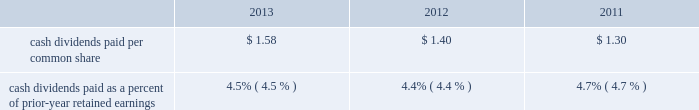Net cash used by investing activities in 2013 also included $ 38.2 million for the may 13 , 2013 acquisition of challenger .
See note 2 to the consolidated financial statements for information on the challenger acquisition .
Capital expenditures in 2013 , 2012 and 2011 totaled $ 70.6 million , $ 79.4 million and $ 61.2 million , respectively .
Capital expenditures in 2013 included continued investments related to the company 2019s execution of its strategic value creation processes around safety , quality , customer connection , innovation and rci initiatives .
Capital expenditures in all three years included spending to support the company 2019s strategic growth initiatives .
In 2013 , the company continued to invest in new product , efficiency , safety and cost reduction initiatives to expand and improve its manufacturing capabilities worldwide .
In 2012 , the company completed the construction of a fourth factory in kunshan , china , following the 2011 construction of a new engineering and research and development facility in kunshan .
Capital expenditures in all three years also included investments , particularly in the united states , in new product , efficiency , safety and cost reduction initiatives , as well as investments in new production and machine tooling to enhance manufacturing operations , and ongoing replacements of manufacturing and distribution equipment .
Capital spending in all three years also included spending for the replacement and enhancement of the company 2019s global enterprise resource planning ( erp ) management information systems , as well as spending to enhance the company 2019s corporate headquarters and research and development facilities in kenosha , wisconsin .
Snap-on believes that its cash generated from operations , as well as its available cash on hand and funds available from its credit facilities will be sufficient to fund the company 2019s capital expenditure requirements in 2014 .
Financing activities net cash used by financing activities was $ 137.8 million in 2013 , $ 127.0 million in 2012 and $ 293.7 million in 2011 .
Net cash used by financing activities in 2011 reflects the august 2011 repayment of $ 200 million of unsecured 6.25% ( 6.25 % ) notes upon maturity with available cash .
Proceeds from stock purchase and option plan exercises totaled $ 29.2 million in 2013 , $ 46.8 million in 2012 and $ 25.7 million in 2011 .
Snap-on has undertaken stock repurchases from time to time to offset dilution created by shares issued for employee and franchisee stock purchase plans , stock options and other corporate purposes .
In 2013 , snap-on repurchased 926000 shares of its common stock for $ 82.6 million under its previously announced share repurchase programs .
As of 2013 year end , snap-on had remaining availability to repurchase up to an additional $ 191.7 million in common stock pursuant to its board of directors 2019 ( the 201cboard 201d ) authorizations .
The purchase of snap-on common stock is at the company 2019s discretion , subject to prevailing financial and market conditions .
Snap-on repurchased 1180000 shares of its common stock for $ 78.1 million in 2012 ; snap-on repurchased 628000 shares of its common stock for $ 37.4 million in 2011 .
Snap-on believes that its cash generated from operations , available cash on hand , and funds available from its credit facilities , will be sufficient to fund the company 2019s share repurchases , if any , in 2014 .
Snap-on has paid consecutive quarterly cash dividends , without interruption or reduction , since 1939 .
Cash dividends paid in 2013 , 2012 and 2011 totaled $ 92.0 million , $ 81.5 million and $ 76.7 million , respectively .
On november 8 , 2013 , the company announced that its board increased the quarterly cash dividend by 15.8% ( 15.8 % ) to $ 0.44 per share ( $ 1.76 per share per year ) .
Quarterly dividends declared in 2013 were $ 0.44 per share in the fourth quarter and $ 0.38 per share in the first three quarters ( $ 1.58 per share for the year ) .
Quarterly dividends declared in 2012 were $ 0.38 per share in the fourth quarter and $ 0.34 per share in the first three quarters ( $ 1.40 per share for the year ) .
Quarterly dividends in 2011 were $ 0.34 per share in the fourth quarter and $ 0.32 per share in the first three quarters ( $ 1.30 per share for the year ) . .
Cash dividends paid as a percent of prior-year retained earnings 4.5% ( 4.5 % ) 4.4% ( 4.4 % ) snap-on believes that its cash generated from operations , available cash on hand and funds available from its credit facilities will be sufficient to pay dividends in 2014 .
Off-balance-sheet arrangements except as included below in the section labeled 201ccontractual obligations and commitments 201d and note 15 to the consolidated financial statements , the company had no off-balance-sheet arrangements as of 2013 year end .
2013 annual report 49 .
What was the average capital expenditures from 2011 to 2013 in millions? 
Computations: (((61.2 + (70.6 + 79.4)) + 3) / 2)
Answer: 107.1. Net cash used by investing activities in 2013 also included $ 38.2 million for the may 13 , 2013 acquisition of challenger .
See note 2 to the consolidated financial statements for information on the challenger acquisition .
Capital expenditures in 2013 , 2012 and 2011 totaled $ 70.6 million , $ 79.4 million and $ 61.2 million , respectively .
Capital expenditures in 2013 included continued investments related to the company 2019s execution of its strategic value creation processes around safety , quality , customer connection , innovation and rci initiatives .
Capital expenditures in all three years included spending to support the company 2019s strategic growth initiatives .
In 2013 , the company continued to invest in new product , efficiency , safety and cost reduction initiatives to expand and improve its manufacturing capabilities worldwide .
In 2012 , the company completed the construction of a fourth factory in kunshan , china , following the 2011 construction of a new engineering and research and development facility in kunshan .
Capital expenditures in all three years also included investments , particularly in the united states , in new product , efficiency , safety and cost reduction initiatives , as well as investments in new production and machine tooling to enhance manufacturing operations , and ongoing replacements of manufacturing and distribution equipment .
Capital spending in all three years also included spending for the replacement and enhancement of the company 2019s global enterprise resource planning ( erp ) management information systems , as well as spending to enhance the company 2019s corporate headquarters and research and development facilities in kenosha , wisconsin .
Snap-on believes that its cash generated from operations , as well as its available cash on hand and funds available from its credit facilities will be sufficient to fund the company 2019s capital expenditure requirements in 2014 .
Financing activities net cash used by financing activities was $ 137.8 million in 2013 , $ 127.0 million in 2012 and $ 293.7 million in 2011 .
Net cash used by financing activities in 2011 reflects the august 2011 repayment of $ 200 million of unsecured 6.25% ( 6.25 % ) notes upon maturity with available cash .
Proceeds from stock purchase and option plan exercises totaled $ 29.2 million in 2013 , $ 46.8 million in 2012 and $ 25.7 million in 2011 .
Snap-on has undertaken stock repurchases from time to time to offset dilution created by shares issued for employee and franchisee stock purchase plans , stock options and other corporate purposes .
In 2013 , snap-on repurchased 926000 shares of its common stock for $ 82.6 million under its previously announced share repurchase programs .
As of 2013 year end , snap-on had remaining availability to repurchase up to an additional $ 191.7 million in common stock pursuant to its board of directors 2019 ( the 201cboard 201d ) authorizations .
The purchase of snap-on common stock is at the company 2019s discretion , subject to prevailing financial and market conditions .
Snap-on repurchased 1180000 shares of its common stock for $ 78.1 million in 2012 ; snap-on repurchased 628000 shares of its common stock for $ 37.4 million in 2011 .
Snap-on believes that its cash generated from operations , available cash on hand , and funds available from its credit facilities , will be sufficient to fund the company 2019s share repurchases , if any , in 2014 .
Snap-on has paid consecutive quarterly cash dividends , without interruption or reduction , since 1939 .
Cash dividends paid in 2013 , 2012 and 2011 totaled $ 92.0 million , $ 81.5 million and $ 76.7 million , respectively .
On november 8 , 2013 , the company announced that its board increased the quarterly cash dividend by 15.8% ( 15.8 % ) to $ 0.44 per share ( $ 1.76 per share per year ) .
Quarterly dividends declared in 2013 were $ 0.44 per share in the fourth quarter and $ 0.38 per share in the first three quarters ( $ 1.58 per share for the year ) .
Quarterly dividends declared in 2012 were $ 0.38 per share in the fourth quarter and $ 0.34 per share in the first three quarters ( $ 1.40 per share for the year ) .
Quarterly dividends in 2011 were $ 0.34 per share in the fourth quarter and $ 0.32 per share in the first three quarters ( $ 1.30 per share for the year ) . .
Cash dividends paid as a percent of prior-year retained earnings 4.5% ( 4.5 % ) 4.4% ( 4.4 % ) snap-on believes that its cash generated from operations , available cash on hand and funds available from its credit facilities will be sufficient to pay dividends in 2014 .
Off-balance-sheet arrangements except as included below in the section labeled 201ccontractual obligations and commitments 201d and note 15 to the consolidated financial statements , the company had no off-balance-sheet arrangements as of 2013 year end .
2013 annual report 49 .
What is the growth rate in dividends paid per common share from 2012 to 2013? 
Computations: ((1.58 - 1.40) / 1.40)
Answer: 0.12857. Net cash used by investing activities in 2013 also included $ 38.2 million for the may 13 , 2013 acquisition of challenger .
See note 2 to the consolidated financial statements for information on the challenger acquisition .
Capital expenditures in 2013 , 2012 and 2011 totaled $ 70.6 million , $ 79.4 million and $ 61.2 million , respectively .
Capital expenditures in 2013 included continued investments related to the company 2019s execution of its strategic value creation processes around safety , quality , customer connection , innovation and rci initiatives .
Capital expenditures in all three years included spending to support the company 2019s strategic growth initiatives .
In 2013 , the company continued to invest in new product , efficiency , safety and cost reduction initiatives to expand and improve its manufacturing capabilities worldwide .
In 2012 , the company completed the construction of a fourth factory in kunshan , china , following the 2011 construction of a new engineering and research and development facility in kunshan .
Capital expenditures in all three years also included investments , particularly in the united states , in new product , efficiency , safety and cost reduction initiatives , as well as investments in new production and machine tooling to enhance manufacturing operations , and ongoing replacements of manufacturing and distribution equipment .
Capital spending in all three years also included spending for the replacement and enhancement of the company 2019s global enterprise resource planning ( erp ) management information systems , as well as spending to enhance the company 2019s corporate headquarters and research and development facilities in kenosha , wisconsin .
Snap-on believes that its cash generated from operations , as well as its available cash on hand and funds available from its credit facilities will be sufficient to fund the company 2019s capital expenditure requirements in 2014 .
Financing activities net cash used by financing activities was $ 137.8 million in 2013 , $ 127.0 million in 2012 and $ 293.7 million in 2011 .
Net cash used by financing activities in 2011 reflects the august 2011 repayment of $ 200 million of unsecured 6.25% ( 6.25 % ) notes upon maturity with available cash .
Proceeds from stock purchase and option plan exercises totaled $ 29.2 million in 2013 , $ 46.8 million in 2012 and $ 25.7 million in 2011 .
Snap-on has undertaken stock repurchases from time to time to offset dilution created by shares issued for employee and franchisee stock purchase plans , stock options and other corporate purposes .
In 2013 , snap-on repurchased 926000 shares of its common stock for $ 82.6 million under its previously announced share repurchase programs .
As of 2013 year end , snap-on had remaining availability to repurchase up to an additional $ 191.7 million in common stock pursuant to its board of directors 2019 ( the 201cboard 201d ) authorizations .
The purchase of snap-on common stock is at the company 2019s discretion , subject to prevailing financial and market conditions .
Snap-on repurchased 1180000 shares of its common stock for $ 78.1 million in 2012 ; snap-on repurchased 628000 shares of its common stock for $ 37.4 million in 2011 .
Snap-on believes that its cash generated from operations , available cash on hand , and funds available from its credit facilities , will be sufficient to fund the company 2019s share repurchases , if any , in 2014 .
Snap-on has paid consecutive quarterly cash dividends , without interruption or reduction , since 1939 .
Cash dividends paid in 2013 , 2012 and 2011 totaled $ 92.0 million , $ 81.5 million and $ 76.7 million , respectively .
On november 8 , 2013 , the company announced that its board increased the quarterly cash dividend by 15.8% ( 15.8 % ) to $ 0.44 per share ( $ 1.76 per share per year ) .
Quarterly dividends declared in 2013 were $ 0.44 per share in the fourth quarter and $ 0.38 per share in the first three quarters ( $ 1.58 per share for the year ) .
Quarterly dividends declared in 2012 were $ 0.38 per share in the fourth quarter and $ 0.34 per share in the first three quarters ( $ 1.40 per share for the year ) .
Quarterly dividends in 2011 were $ 0.34 per share in the fourth quarter and $ 0.32 per share in the first three quarters ( $ 1.30 per share for the year ) . .
Cash dividends paid as a percent of prior-year retained earnings 4.5% ( 4.5 % ) 4.4% ( 4.4 % ) snap-on believes that its cash generated from operations , available cash on hand and funds available from its credit facilities will be sufficient to pay dividends in 2014 .
Off-balance-sheet arrangements except as included below in the section labeled 201ccontractual obligations and commitments 201d and note 15 to the consolidated financial statements , the company had no off-balance-sheet arrangements as of 2013 year end .
2013 annual report 49 .
How many share were outstanding in 2013 based on the amount paid for dividends? 
Computations: ((92.0 * 1000000) / 1.58)
Answer: 58227848.10127. Net cash used by investing activities in 2013 also included $ 38.2 million for the may 13 , 2013 acquisition of challenger .
See note 2 to the consolidated financial statements for information on the challenger acquisition .
Capital expenditures in 2013 , 2012 and 2011 totaled $ 70.6 million , $ 79.4 million and $ 61.2 million , respectively .
Capital expenditures in 2013 included continued investments related to the company 2019s execution of its strategic value creation processes around safety , quality , customer connection , innovation and rci initiatives .
Capital expenditures in all three years included spending to support the company 2019s strategic growth initiatives .
In 2013 , the company continued to invest in new product , efficiency , safety and cost reduction initiatives to expand and improve its manufacturing capabilities worldwide .
In 2012 , the company completed the construction of a fourth factory in kunshan , china , following the 2011 construction of a new engineering and research and development facility in kunshan .
Capital expenditures in all three years also included investments , particularly in the united states , in new product , efficiency , safety and cost reduction initiatives , as well as investments in new production and machine tooling to enhance manufacturing operations , and ongoing replacements of manufacturing and distribution equipment .
Capital spending in all three years also included spending for the replacement and enhancement of the company 2019s global enterprise resource planning ( erp ) management information systems , as well as spending to enhance the company 2019s corporate headquarters and research and development facilities in kenosha , wisconsin .
Snap-on believes that its cash generated from operations , as well as its available cash on hand and funds available from its credit facilities will be sufficient to fund the company 2019s capital expenditure requirements in 2014 .
Financing activities net cash used by financing activities was $ 137.8 million in 2013 , $ 127.0 million in 2012 and $ 293.7 million in 2011 .
Net cash used by financing activities in 2011 reflects the august 2011 repayment of $ 200 million of unsecured 6.25% ( 6.25 % ) notes upon maturity with available cash .
Proceeds from stock purchase and option plan exercises totaled $ 29.2 million in 2013 , $ 46.8 million in 2012 and $ 25.7 million in 2011 .
Snap-on has undertaken stock repurchases from time to time to offset dilution created by shares issued for employee and franchisee stock purchase plans , stock options and other corporate purposes .
In 2013 , snap-on repurchased 926000 shares of its common stock for $ 82.6 million under its previously announced share repurchase programs .
As of 2013 year end , snap-on had remaining availability to repurchase up to an additional $ 191.7 million in common stock pursuant to its board of directors 2019 ( the 201cboard 201d ) authorizations .
The purchase of snap-on common stock is at the company 2019s discretion , subject to prevailing financial and market conditions .
Snap-on repurchased 1180000 shares of its common stock for $ 78.1 million in 2012 ; snap-on repurchased 628000 shares of its common stock for $ 37.4 million in 2011 .
Snap-on believes that its cash generated from operations , available cash on hand , and funds available from its credit facilities , will be sufficient to fund the company 2019s share repurchases , if any , in 2014 .
Snap-on has paid consecutive quarterly cash dividends , without interruption or reduction , since 1939 .
Cash dividends paid in 2013 , 2012 and 2011 totaled $ 92.0 million , $ 81.5 million and $ 76.7 million , respectively .
On november 8 , 2013 , the company announced that its board increased the quarterly cash dividend by 15.8% ( 15.8 % ) to $ 0.44 per share ( $ 1.76 per share per year ) .
Quarterly dividends declared in 2013 were $ 0.44 per share in the fourth quarter and $ 0.38 per share in the first three quarters ( $ 1.58 per share for the year ) .
Quarterly dividends declared in 2012 were $ 0.38 per share in the fourth quarter and $ 0.34 per share in the first three quarters ( $ 1.40 per share for the year ) .
Quarterly dividends in 2011 were $ 0.34 per share in the fourth quarter and $ 0.32 per share in the first three quarters ( $ 1.30 per share for the year ) . .
Cash dividends paid as a percent of prior-year retained earnings 4.5% ( 4.5 % ) 4.4% ( 4.4 % ) snap-on believes that its cash generated from operations , available cash on hand and funds available from its credit facilities will be sufficient to pay dividends in 2014 .
Off-balance-sheet arrangements except as included below in the section labeled 201ccontractual obligations and commitments 201d and note 15 to the consolidated financial statements , the company had no off-balance-sheet arrangements as of 2013 year end .
2013 annual report 49 .
What was the average cash dividends paid per common share from 2011 to 2013? 
Computations: (((1.30 + (1.58 + 1.40)) + 3) / 2)
Answer: 3.64. 